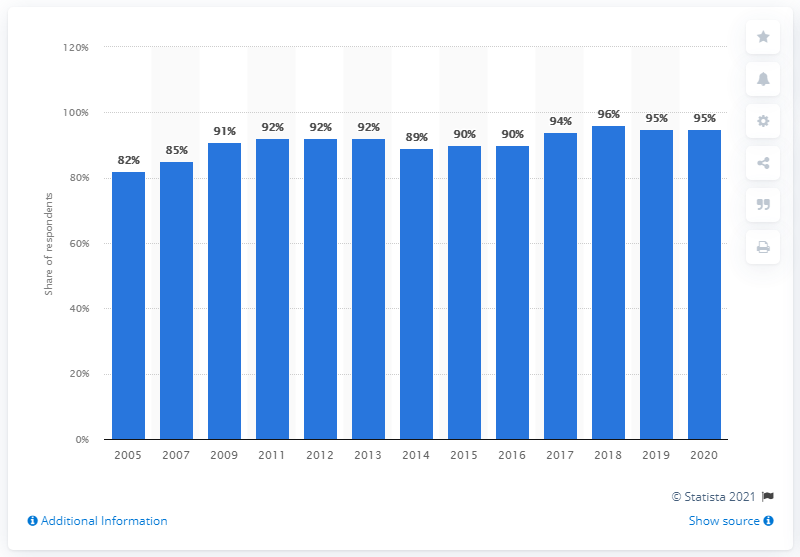Give some essential details in this illustration. In 2020, approximately 95% of adults in the UK were using mobile phones. 